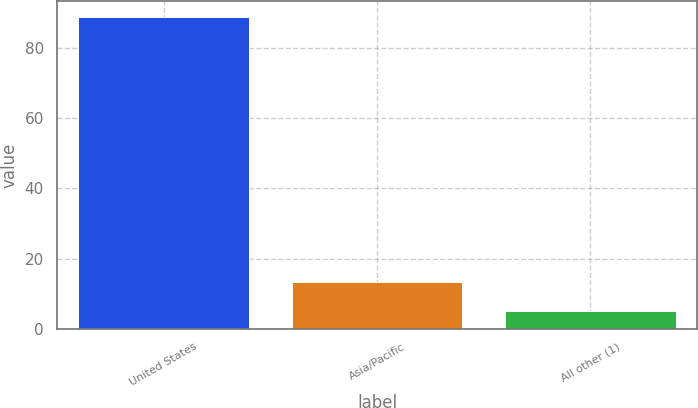Convert chart. <chart><loc_0><loc_0><loc_500><loc_500><bar_chart><fcel>United States<fcel>Asia/Pacific<fcel>All other (1)<nl><fcel>89<fcel>13.4<fcel>5<nl></chart> 